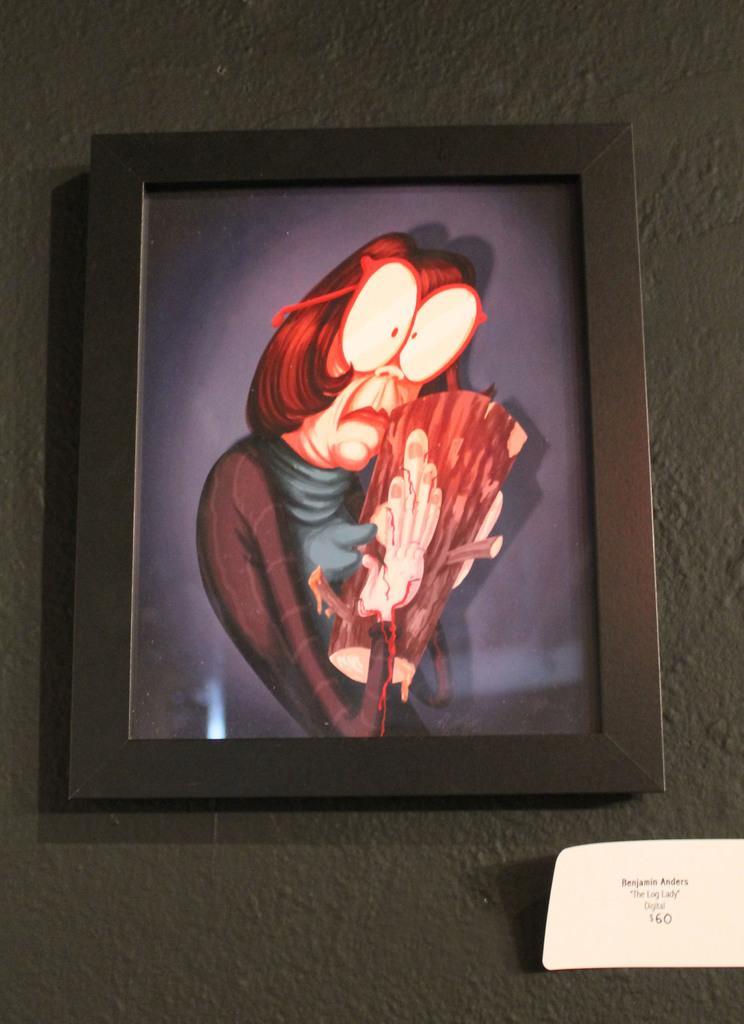In one or two sentences, can you explain what this image depicts? In this image we can see the wall with a photo frame. 